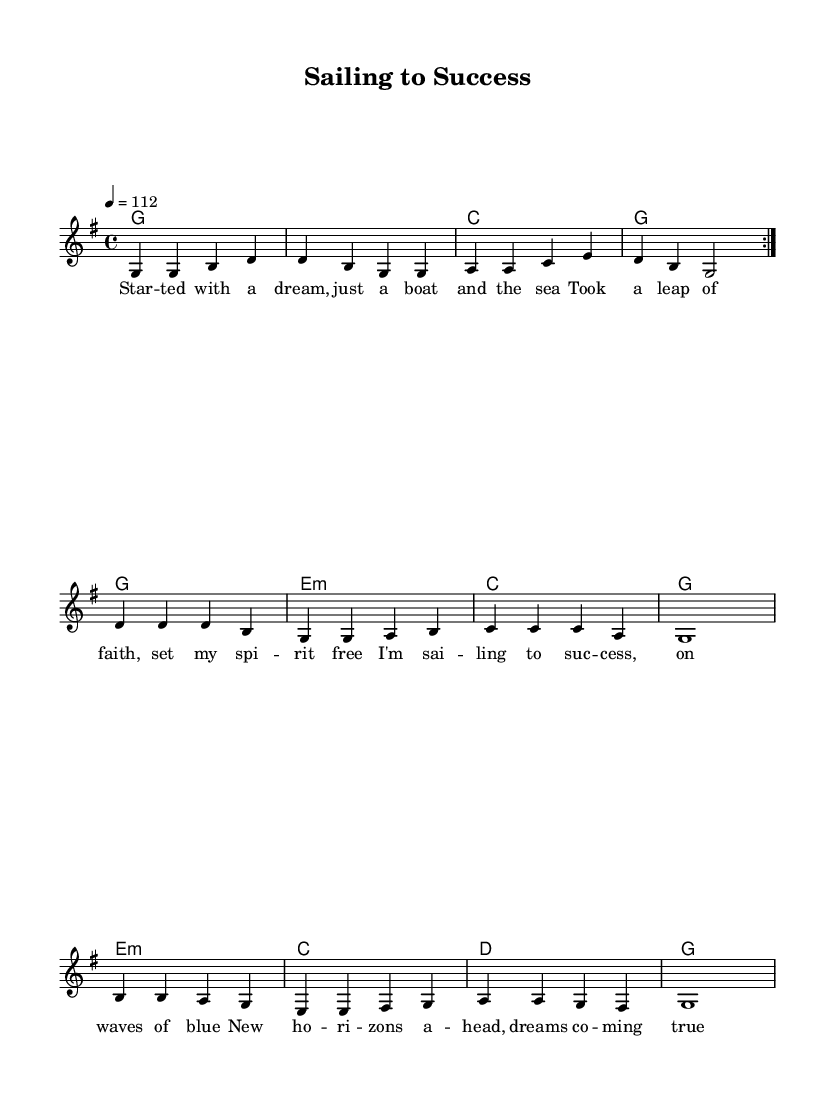What is the key signature of this music? The music is in G major, which has one sharp (F#) in its key signature. This can be identified from the presence of the key signature marked by the 'g' in the global section of the code.
Answer: G major What is the time signature of this music? The time signature is 4/4, indicated in the global section of the code by the line `\time 4/4`. This means there are four beats in each measure.
Answer: 4/4 What is the tempo marking of this piece? The tempo is marked as 112 beats per minute, noted in the code as `\tempo 4 = 112`. This guides the speed at which the piece should be played.
Answer: 112 How many times is the melody repeated? The melody is repeated twice, as indicated by `\repeat volta 2` in the code. This shows that the section inside the repeat should be played two times.
Answer: 2 What is the primary theme of the lyrics in this music? The lyrics focus on embarking on a journey and celebrating success, as highlighted in the main phrases throughout the sections. This theme aligns with entrepreneurial success.
Answer: Success What is the function of the bridge in this song structure? The bridge serves as a contrast to the verses and chorus, typically providing a different emotional perspective or narrative twist in the song. Here, it reflects on personal growth through challenges.
Answer: Contrast Which chord appears in the last measure of the harmonies? The last measure contains the G major chord, notated simply by `g` at the end of the harmonies section. This confirms the home key and resolution of the piece.
Answer: G 